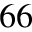Convert formula to latex. <formula><loc_0><loc_0><loc_500><loc_500>^ { 6 6 }</formula> 